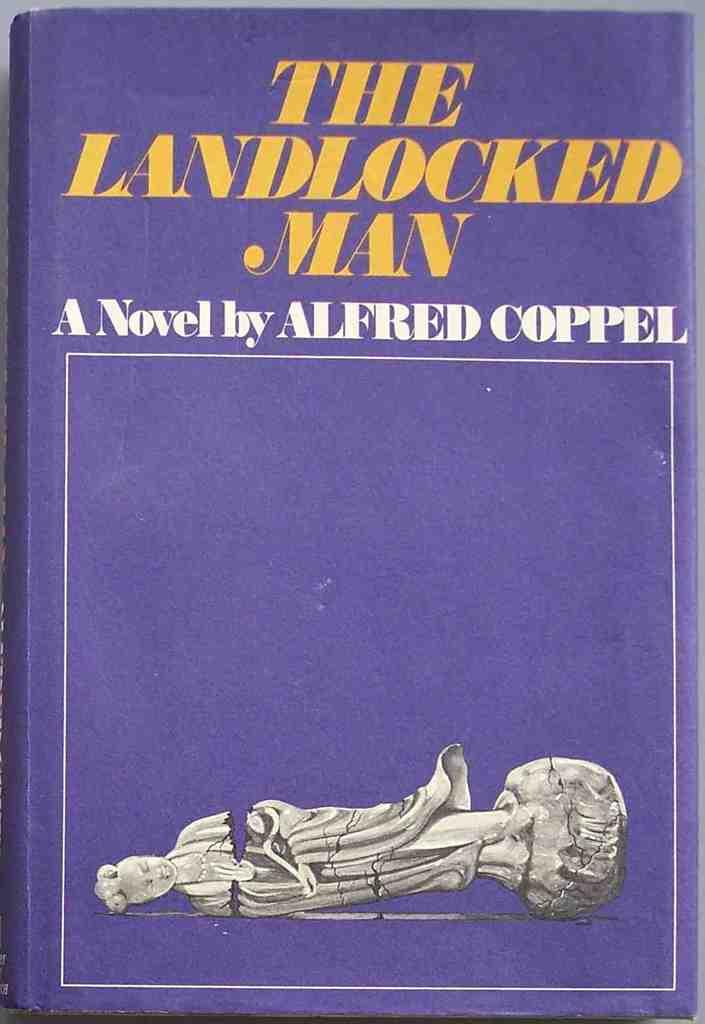<image>
Share a concise interpretation of the image provided. The cover for the book titled the landlocked man by alfred coppel. 